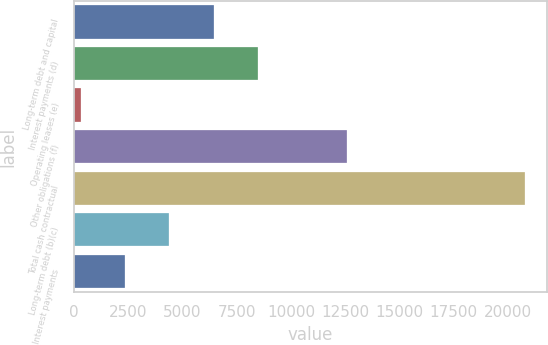<chart> <loc_0><loc_0><loc_500><loc_500><bar_chart><fcel>Long-term debt and capital<fcel>Interest payments (d)<fcel>Operating leases (e)<fcel>Other obligations (f)<fcel>Total cash contractual<fcel>Long-term debt (b)(c)<fcel>Interest payments<nl><fcel>6446.8<fcel>8493.4<fcel>307<fcel>12586.6<fcel>20773<fcel>4400.2<fcel>2353.6<nl></chart> 